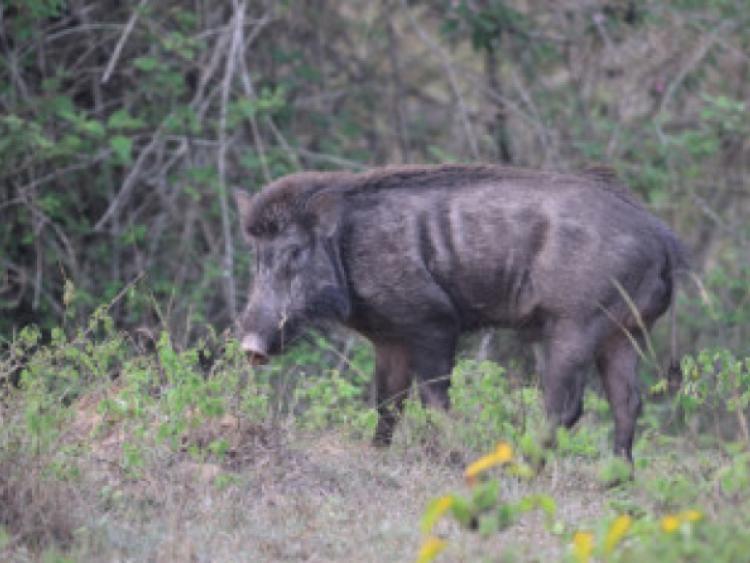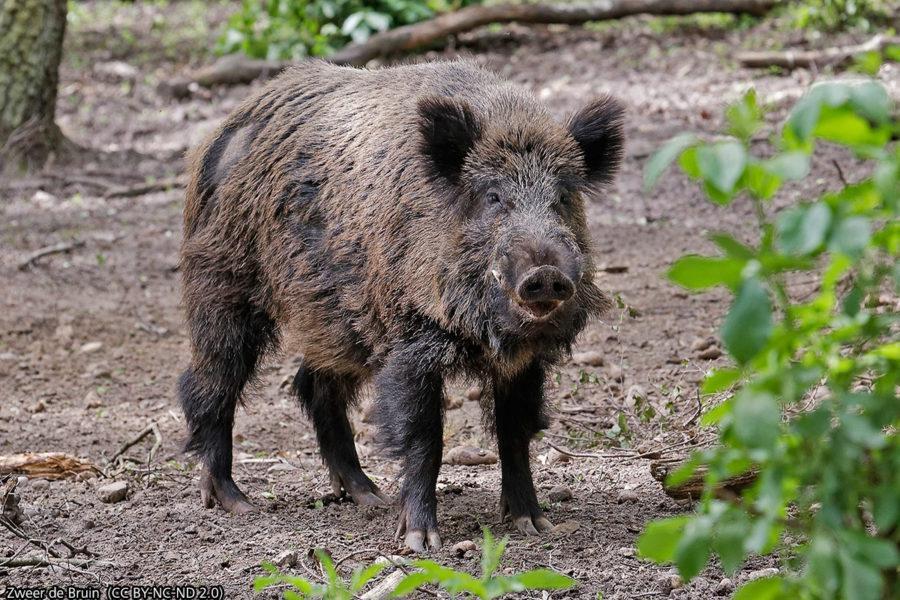The first image is the image on the left, the second image is the image on the right. Evaluate the accuracy of this statement regarding the images: "A single wild pig stands in the grass in the image on the left.". Is it true? Answer yes or no. Yes. The first image is the image on the left, the second image is the image on the right. Given the left and right images, does the statement "Each image shows exactly one wild boar." hold true? Answer yes or no. Yes. 